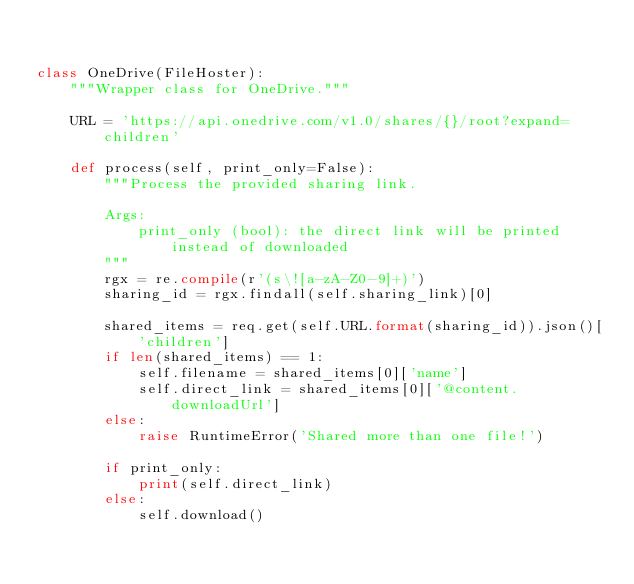Convert code to text. <code><loc_0><loc_0><loc_500><loc_500><_Python_>

class OneDrive(FileHoster):
    """Wrapper class for OneDrive."""

    URL = 'https://api.onedrive.com/v1.0/shares/{}/root?expand=children'

    def process(self, print_only=False):
        """Process the provided sharing link.

        Args:
            print_only (bool): the direct link will be printed instead of downloaded
        """
        rgx = re.compile(r'(s\![a-zA-Z0-9]+)')
        sharing_id = rgx.findall(self.sharing_link)[0]

        shared_items = req.get(self.URL.format(sharing_id)).json()['children']
        if len(shared_items) == 1:
            self.filename = shared_items[0]['name']
            self.direct_link = shared_items[0]['@content.downloadUrl']
        else:
            raise RuntimeError('Shared more than one file!')

        if print_only:
            print(self.direct_link)
        else:
            self.download()
</code> 